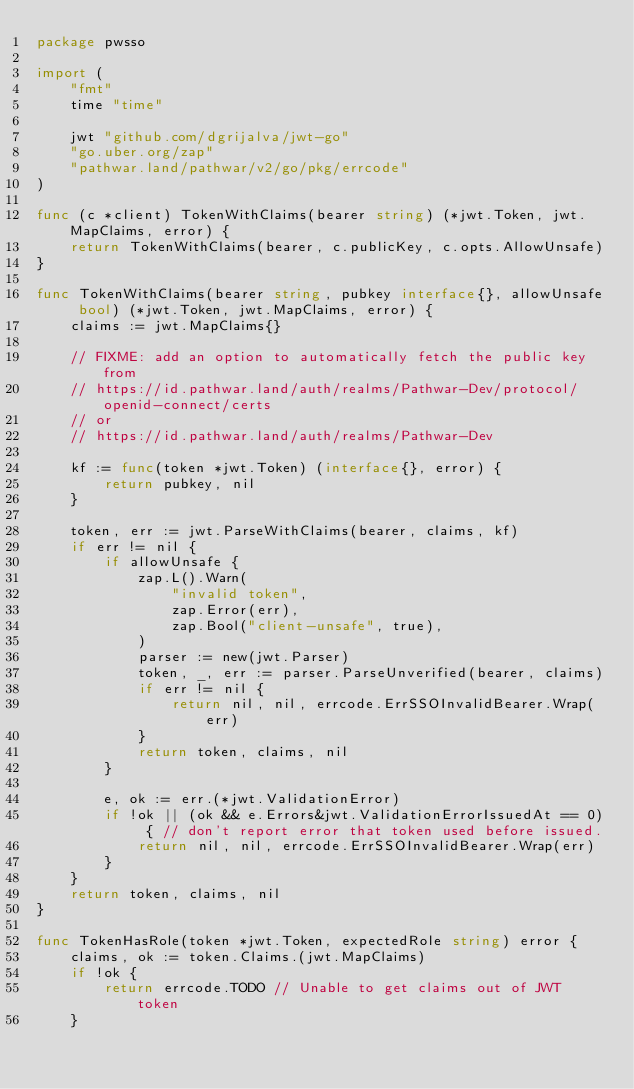<code> <loc_0><loc_0><loc_500><loc_500><_Go_>package pwsso

import (
	"fmt"
	time "time"

	jwt "github.com/dgrijalva/jwt-go"
	"go.uber.org/zap"
	"pathwar.land/pathwar/v2/go/pkg/errcode"
)

func (c *client) TokenWithClaims(bearer string) (*jwt.Token, jwt.MapClaims, error) {
	return TokenWithClaims(bearer, c.publicKey, c.opts.AllowUnsafe)
}

func TokenWithClaims(bearer string, pubkey interface{}, allowUnsafe bool) (*jwt.Token, jwt.MapClaims, error) {
	claims := jwt.MapClaims{}

	// FIXME: add an option to automatically fetch the public key from
	// https://id.pathwar.land/auth/realms/Pathwar-Dev/protocol/openid-connect/certs
	// or
	// https://id.pathwar.land/auth/realms/Pathwar-Dev

	kf := func(token *jwt.Token) (interface{}, error) {
		return pubkey, nil
	}

	token, err := jwt.ParseWithClaims(bearer, claims, kf)
	if err != nil {
		if allowUnsafe {
			zap.L().Warn(
				"invalid token",
				zap.Error(err),
				zap.Bool("client-unsafe", true),
			)
			parser := new(jwt.Parser)
			token, _, err := parser.ParseUnverified(bearer, claims)
			if err != nil {
				return nil, nil, errcode.ErrSSOInvalidBearer.Wrap(err)
			}
			return token, claims, nil
		}

		e, ok := err.(*jwt.ValidationError)
		if !ok || (ok && e.Errors&jwt.ValidationErrorIssuedAt == 0) { // don't report error that token used before issued.
			return nil, nil, errcode.ErrSSOInvalidBearer.Wrap(err)
		}
	}
	return token, claims, nil
}

func TokenHasRole(token *jwt.Token, expectedRole string) error {
	claims, ok := token.Claims.(jwt.MapClaims)
	if !ok {
		return errcode.TODO // Unable to get claims out of JWT token
	}</code> 